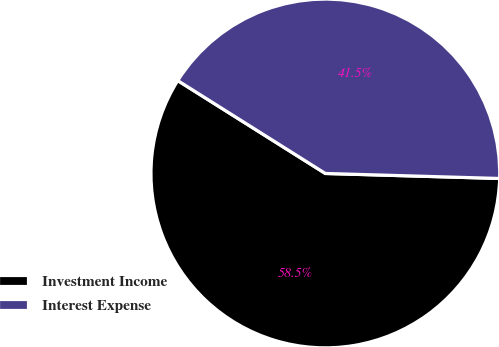<chart> <loc_0><loc_0><loc_500><loc_500><pie_chart><fcel>Investment Income<fcel>Interest Expense<nl><fcel>58.48%<fcel>41.52%<nl></chart> 